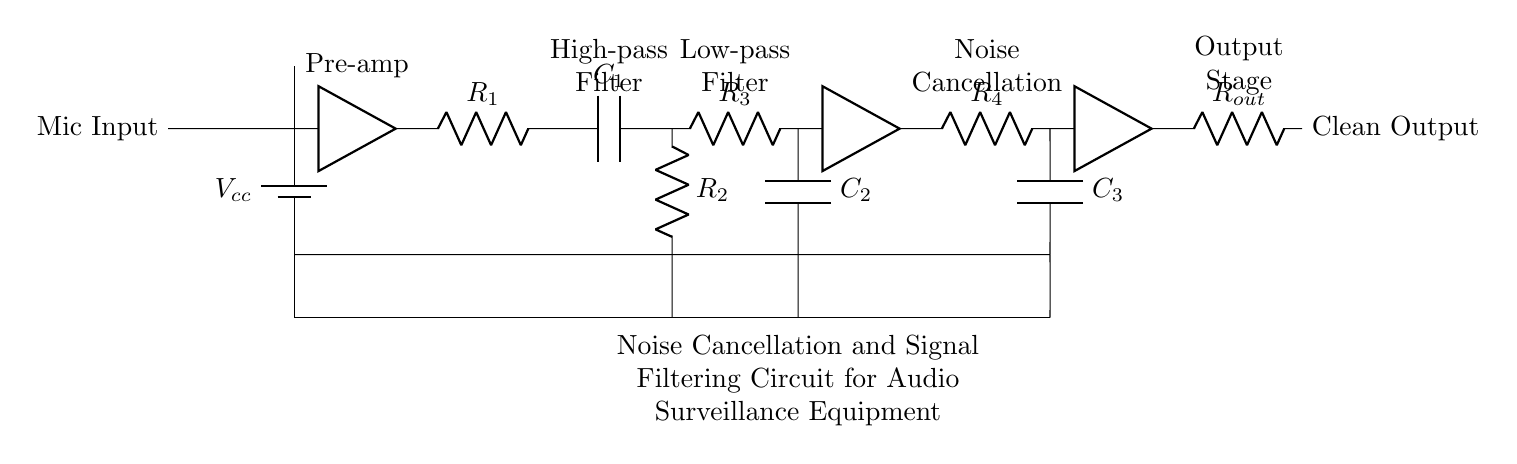What is the power supply voltage for this circuit? The circuit is powered by a battery labeled Vcc, which typically indicates the power supply voltage. In this case, the exact value is not provided on the diagram, but it is generally a specified voltage, like five volts or twelve volts, in practical applications.
Answer: Vcc Which component is responsible for amplifying the microphone input? The pre-amplifier component is shown as an amplifier in the diagram; it directly connects to the microphone input and amplifies the weak audio signals from it before passing through the filters.
Answer: Pre-amplifier What is the purpose of the high-pass filter in this circuit? The high-pass filter, composed of resistor R2 and capacitor C1, allows high-frequency signals to pass through while attenuating lower-frequency signals, effectively reducing noise below a certain frequency level and improving audio clarity.
Answer: Attenuate low frequencies How many amplification stages are present in the circuit? By examining the component labeled as amplifier, there are two such stages in the circuit—one in the pre-amplifier section and another in the output stage of the noise cancellation circuit—indicating the need for multiple amplification processes to enhance the audio signal effectively.
Answer: Two What does the low-pass filter do in this circuit? The low-pass filter consists of resistor R3 and capacitor C2 and is designed to allow low-frequency signals to pass while blocking or attenuating higher-frequency noise, thus ensuring that the final output contains mostly the intended audio signals and less unwanted high-frequency noise.
Answer: Allow low frequencies What final output does the circuit produce? The final output stage is designated as Clean Output in the diagram, indicating that the processed audio signals, after passing through noise cancellation and filtering stages, are made available for further use, such as recording or analysis.
Answer: Clean Output 